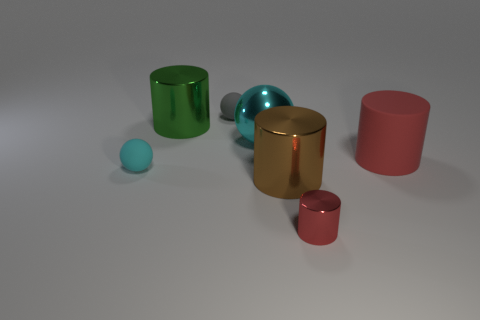Subtract 2 cyan balls. How many objects are left? 5 Subtract all cylinders. How many objects are left? 3 Subtract all brown cylinders. Subtract all brown balls. How many cylinders are left? 3 Subtract all gray blocks. How many purple cylinders are left? 0 Subtract all small yellow things. Subtract all matte balls. How many objects are left? 5 Add 6 red metallic cylinders. How many red metallic cylinders are left? 7 Add 4 yellow balls. How many yellow balls exist? 4 Add 1 small gray matte balls. How many objects exist? 8 Subtract all red cylinders. How many cylinders are left? 2 Subtract all gray rubber balls. How many balls are left? 2 